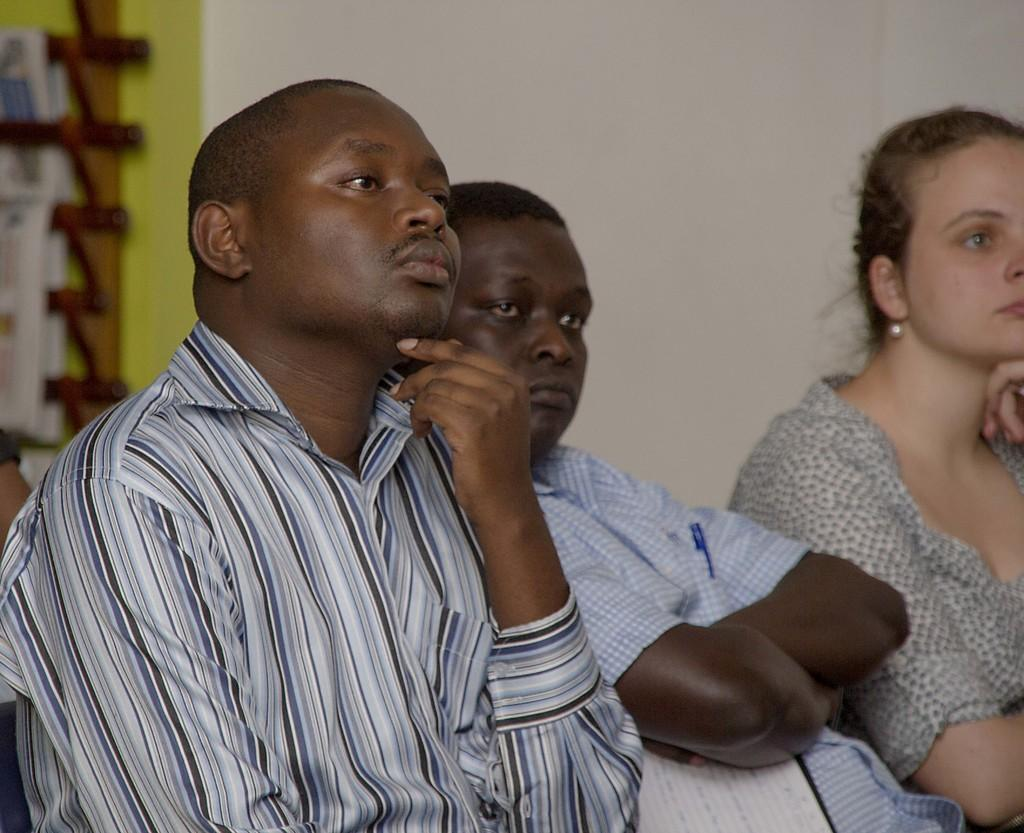How many people are in the image? There are two men and one woman in the image, making a total of three people. What are the individuals in the image doing? The individuals are sitting and watching something. What can be seen in the background of the image? There is a wall visible in the background of the image. What is on the rack in the image? There is a rack with papers in the image. What color is the balloon floating above the woman's stomach in the image? There is no balloon present in the image, and the woman's stomach is not mentioned in the facts provided. 